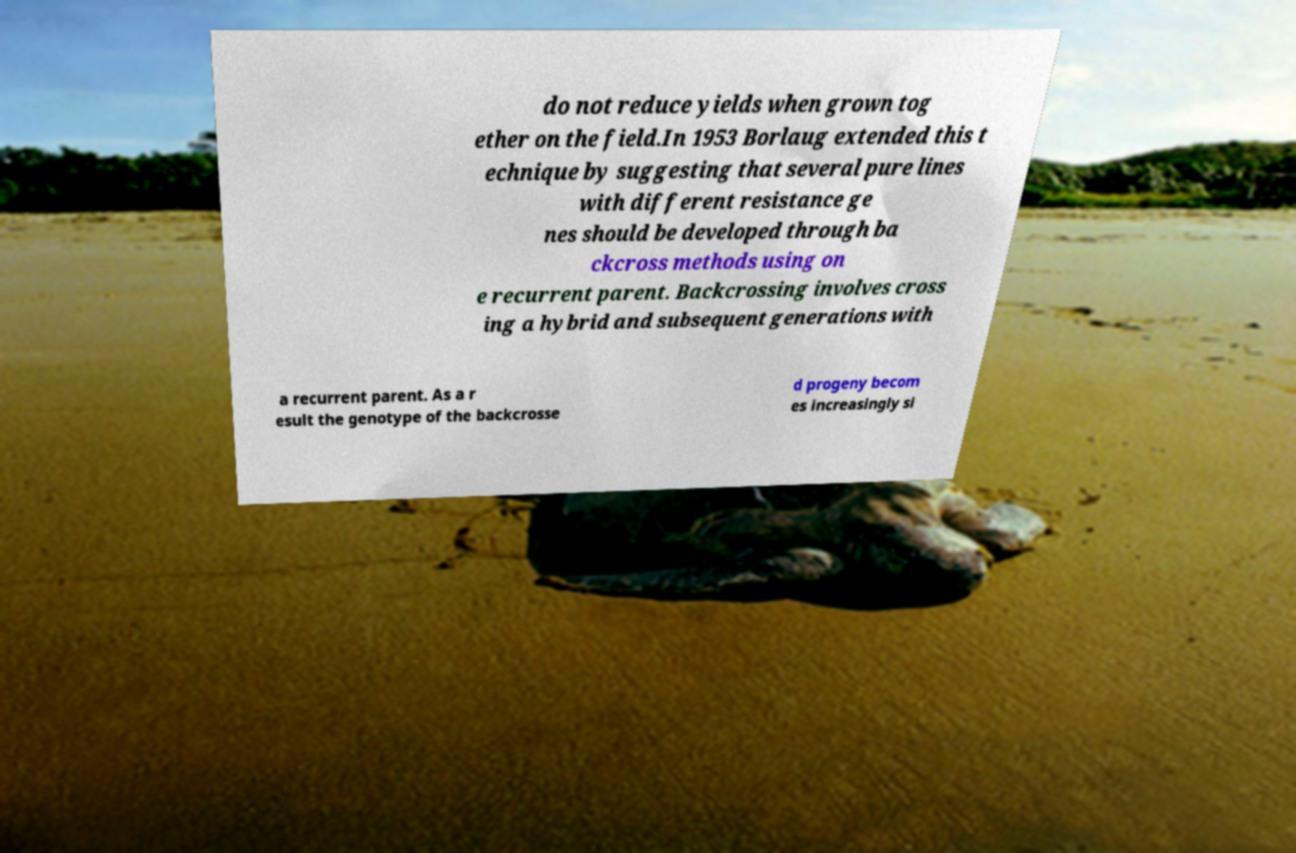What messages or text are displayed in this image? I need them in a readable, typed format. do not reduce yields when grown tog ether on the field.In 1953 Borlaug extended this t echnique by suggesting that several pure lines with different resistance ge nes should be developed through ba ckcross methods using on e recurrent parent. Backcrossing involves cross ing a hybrid and subsequent generations with a recurrent parent. As a r esult the genotype of the backcrosse d progeny becom es increasingly si 